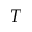<formula> <loc_0><loc_0><loc_500><loc_500>T</formula> 